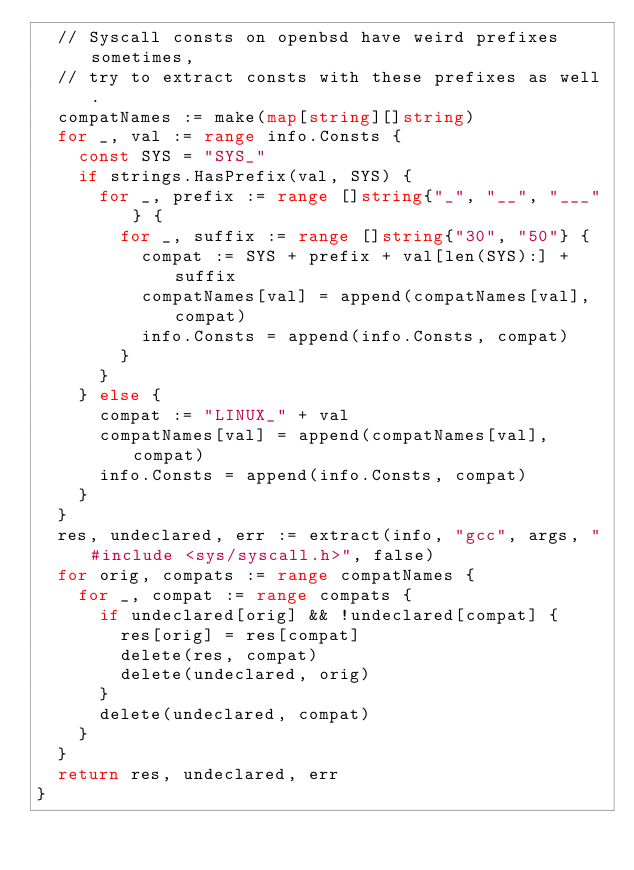Convert code to text. <code><loc_0><loc_0><loc_500><loc_500><_Go_>	// Syscall consts on openbsd have weird prefixes sometimes,
	// try to extract consts with these prefixes as well.
	compatNames := make(map[string][]string)
	for _, val := range info.Consts {
		const SYS = "SYS_"
		if strings.HasPrefix(val, SYS) {
			for _, prefix := range []string{"_", "__", "___"} {
				for _, suffix := range []string{"30", "50"} {
					compat := SYS + prefix + val[len(SYS):] + suffix
					compatNames[val] = append(compatNames[val], compat)
					info.Consts = append(info.Consts, compat)
				}
			}
		} else {
			compat := "LINUX_" + val
			compatNames[val] = append(compatNames[val], compat)
			info.Consts = append(info.Consts, compat)
		}
	}
	res, undeclared, err := extract(info, "gcc", args, "#include <sys/syscall.h>", false)
	for orig, compats := range compatNames {
		for _, compat := range compats {
			if undeclared[orig] && !undeclared[compat] {
				res[orig] = res[compat]
				delete(res, compat)
				delete(undeclared, orig)
			}
			delete(undeclared, compat)
		}
	}
	return res, undeclared, err
}
</code> 